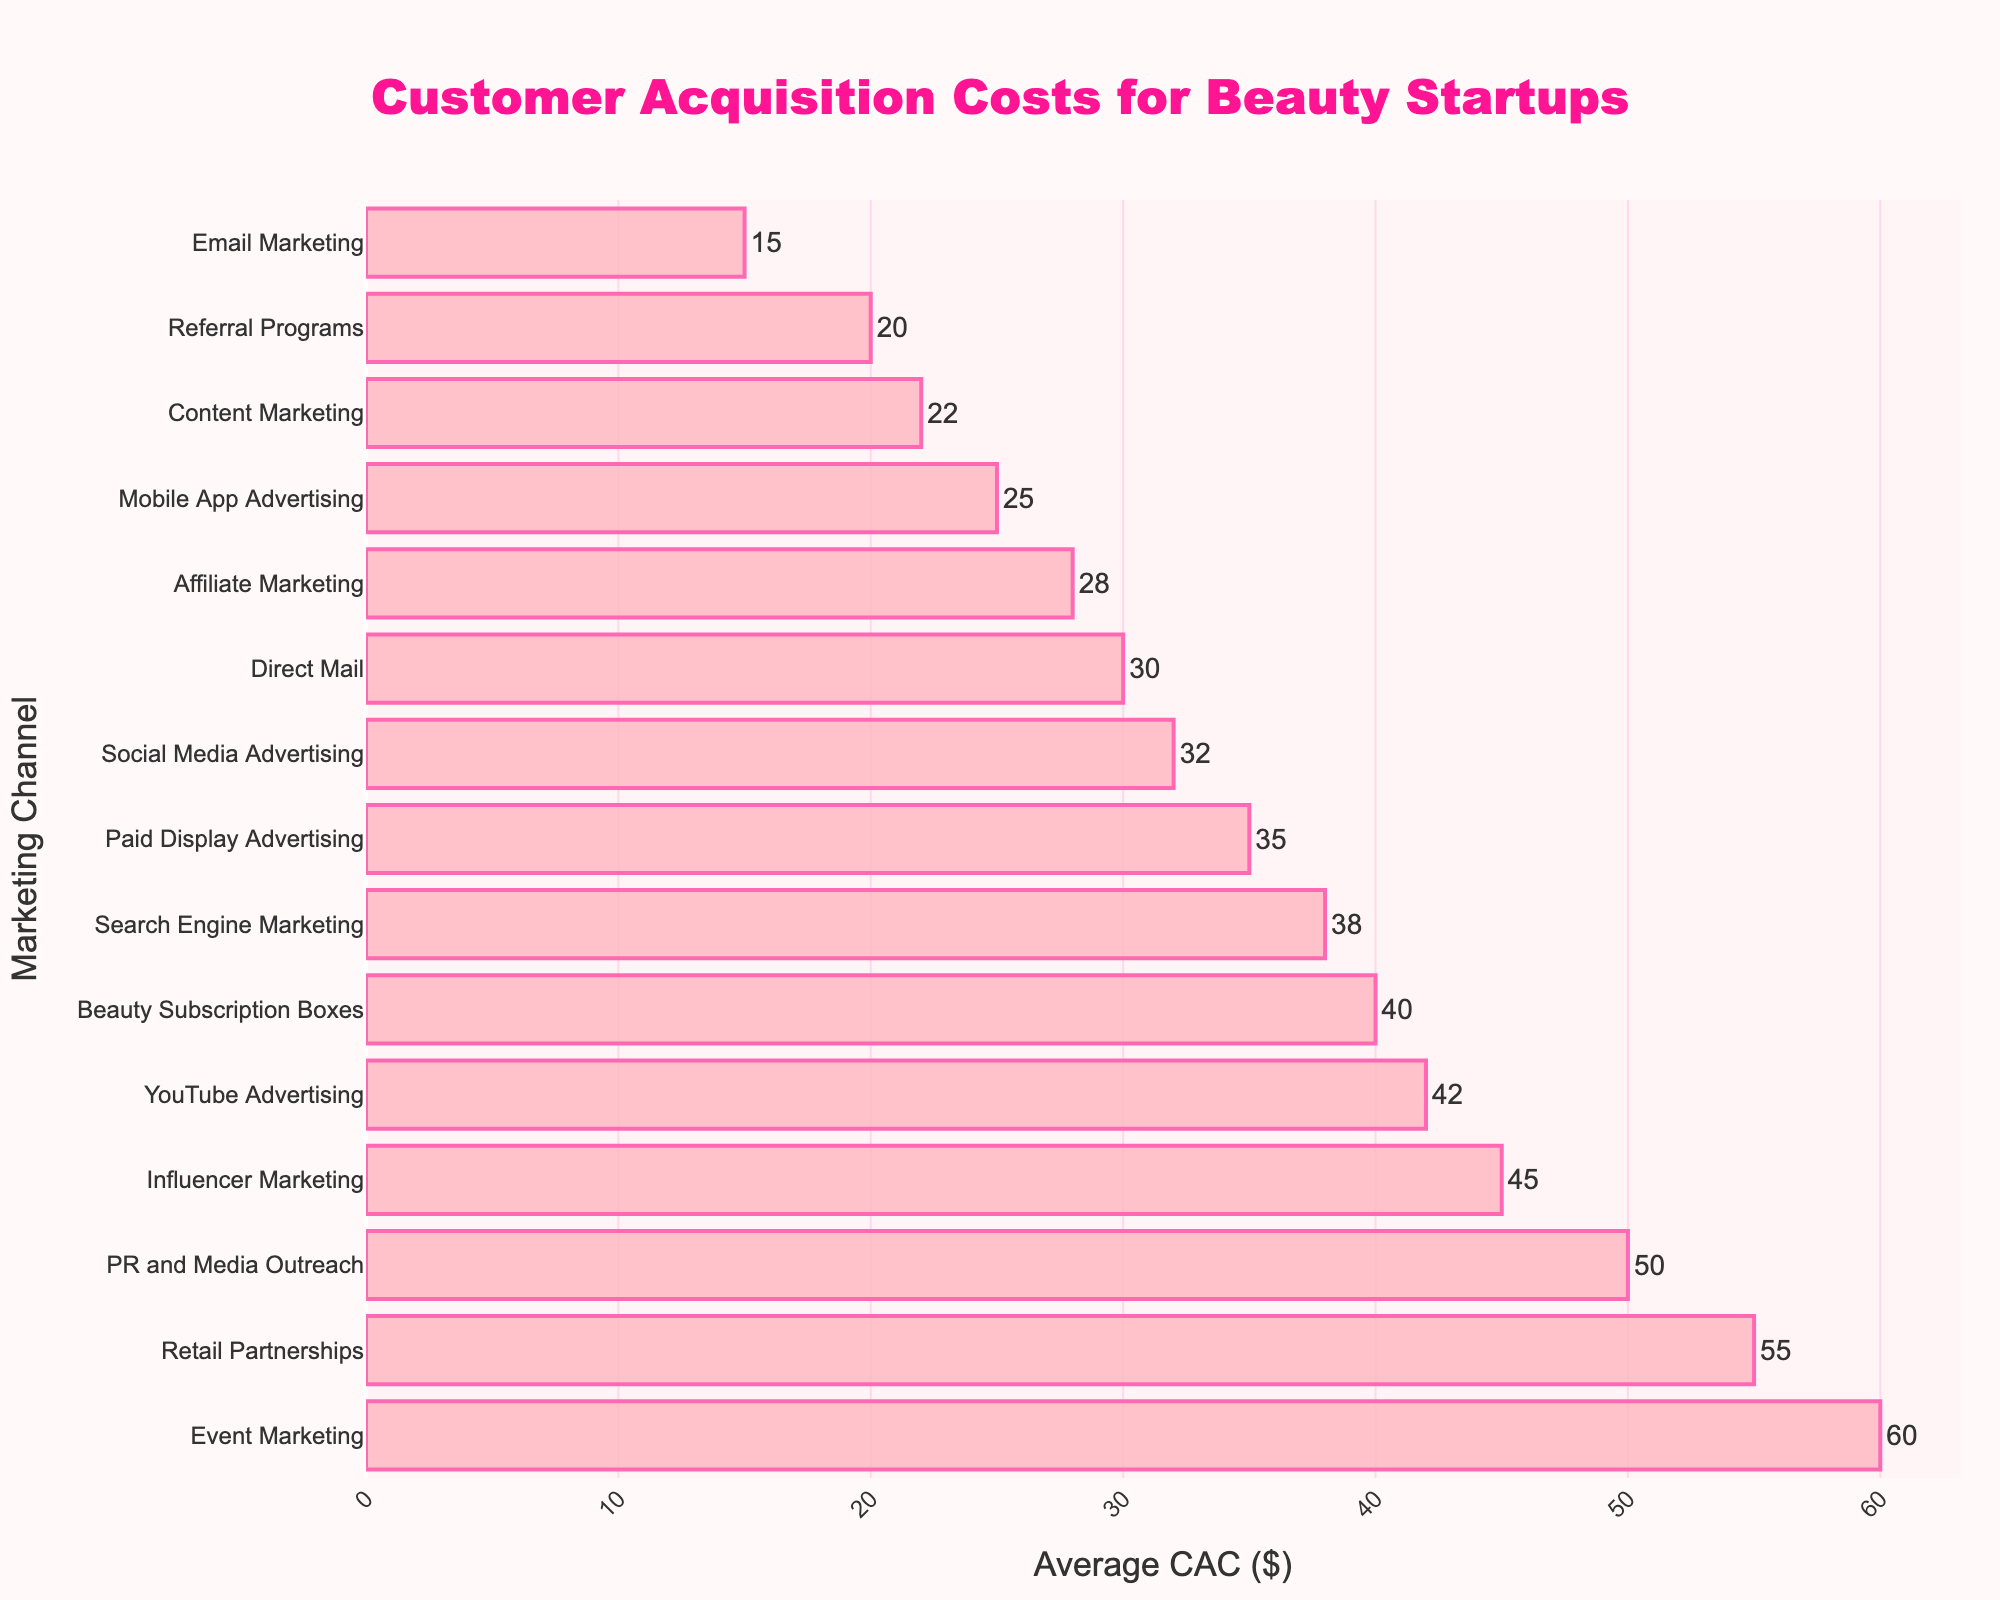Which channel has the highest customer acquisition cost? The bar corresponding to Retail Partnerships is the longest and reaches the highest value on the x-axis. Thus, Retail Partnerships has the highest customer acquisition cost.
Answer: Retail Partnerships Which channel has the lowest customer acquisition cost? The bar for Email Marketing is the shortest and has the lowest value on the x-axis. Thus, Email Marketing has the lowest customer acquisition cost.
Answer: Email Marketing How much higher is the cost of Event Marketing compared to Social Media Advertising? The Event Marketing bar has a value of $60, while the Social Media Advertising bar has a value of $32. The difference between these values is $60 - $32.
Answer: $28 What is the median customer acquisition cost among all channels? First, arrange all the CAC values in ascending order: 15, 20, 22, 25, 28, 30, 32, 35, 38, 40, 42, 45, 50, 55, 60. Since there are 15 data points, the median value is the 8th value in this ordered list, which is 35.
Answer: $35 What’s the total customer acquisition cost for Influencer Marketing, PR and Media Outreach, and YouTube Advertising combined? The CAC for Influencer Marketing is $45, for PR and Media Outreach is $50, and for YouTube Advertising is $42. Adding these values gives 45 + 50 + 42 = 137.
Answer: $137 How does the CAC of Mobile App Advertising compare to that of Affiliate Marketing? The bar for Mobile App Advertising has a value of $25, while the bar for Affiliate Marketing has a value of $28. Mobile App Advertising has a lower cost by $28 - $25 = $3.
Answer: Mobile App Advertising is $3 less Which channels have a CAC below $30? The channels with bars reaching values below $30 are Email Marketing (15), Referral Programs (20), Content Marketing (22), and Mobile App Advertising (25).
Answer: Email Marketing, Referral Programs, Content Marketing, and Mobile App Advertising How much greater is the CAC of Retail Partnerships compared to Email Marketing? The CAC for Retail Partnerships is $55 and for Email Marketing is $15. The difference is $55 - $15.
Answer: $40 Are there more channels with a CAC above $40 or below $30? Counting the bars: Above $40 there are 5 channels (Influencer Marketing, Beauty Subscription Boxes, YouTube Advertising, PR and Media Outreach, Retail Partnerships, Event Marketing). Below $30, there are 4 channels (Email Marketing, Referral Programs, Content Marketing, Mobile App Advertising). So, there are more channels above $40.
Answer: Above $40 What's the average CAC of all channels combined? Summing all the values: 32 + 45 + 38 + 15 + 22 + 28 + 50 + 20 + 35 + 55 + 40 + 30 + 60 + 25 + 42 = 537. There are 15 channels, so the average is 537 / 15.
Answer: $35.8 